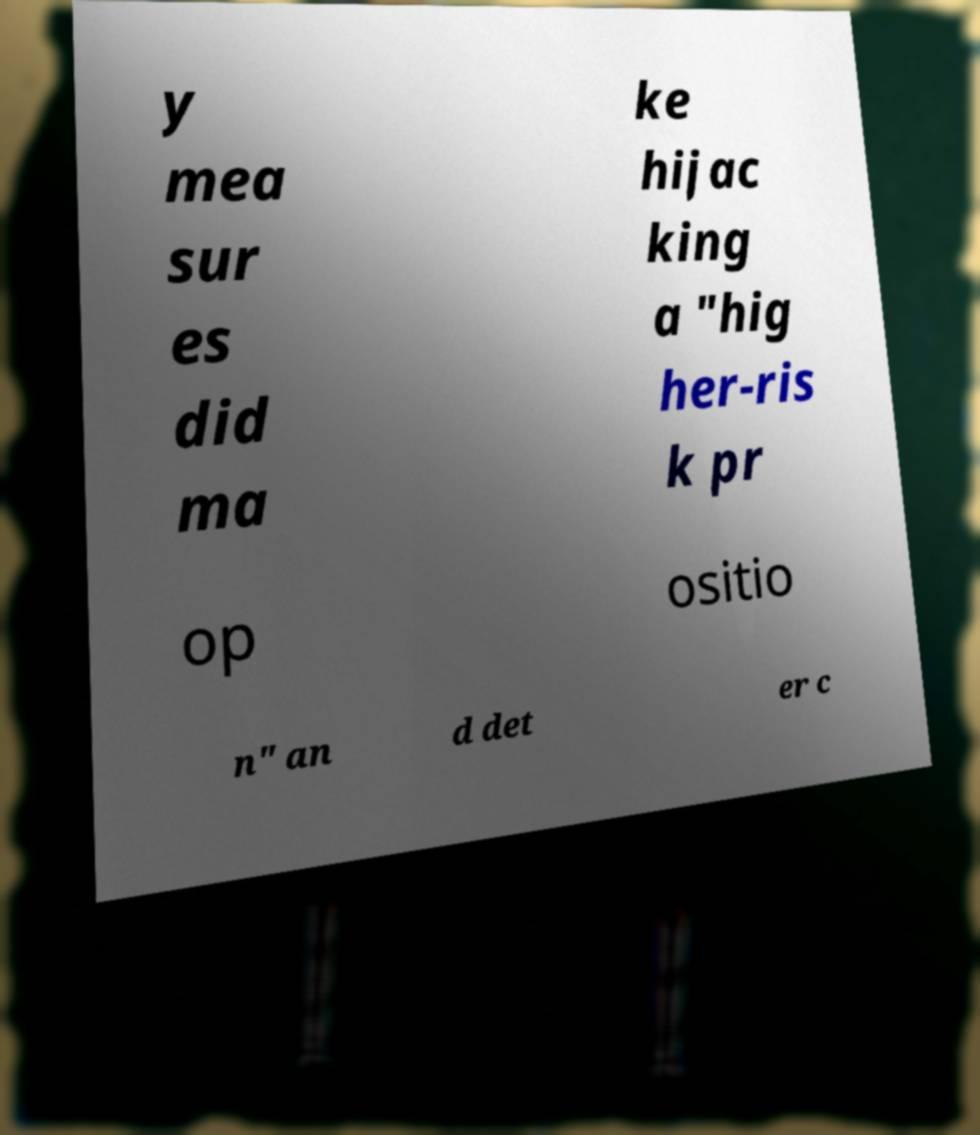Can you accurately transcribe the text from the provided image for me? y mea sur es did ma ke hijac king a "hig her-ris k pr op ositio n" an d det er c 